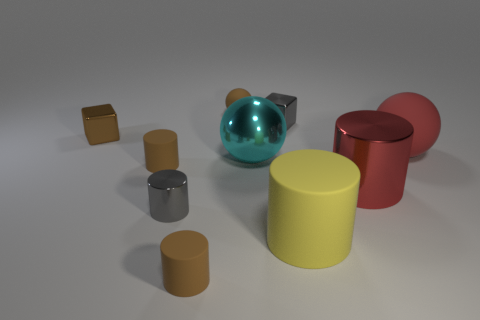What number of other objects are there of the same size as the yellow rubber object?
Provide a succinct answer. 3. The metallic ball is what color?
Your answer should be very brief. Cyan. Is the color of the big sphere that is to the left of the yellow matte object the same as the large metal thing to the right of the yellow cylinder?
Make the answer very short. No. The red matte sphere is what size?
Ensure brevity in your answer.  Large. What is the size of the metal cylinder right of the cyan metallic ball?
Ensure brevity in your answer.  Large. What is the shape of the shiny object that is right of the cyan shiny sphere and in front of the tiny brown cube?
Offer a terse response. Cylinder. What number of other objects are the same shape as the red matte object?
Your response must be concise. 2. There is a metallic sphere that is the same size as the red matte sphere; what is its color?
Offer a terse response. Cyan. How many objects are either big cylinders or yellow cylinders?
Your response must be concise. 2. There is a big yellow rubber object; are there any small objects in front of it?
Make the answer very short. Yes. 